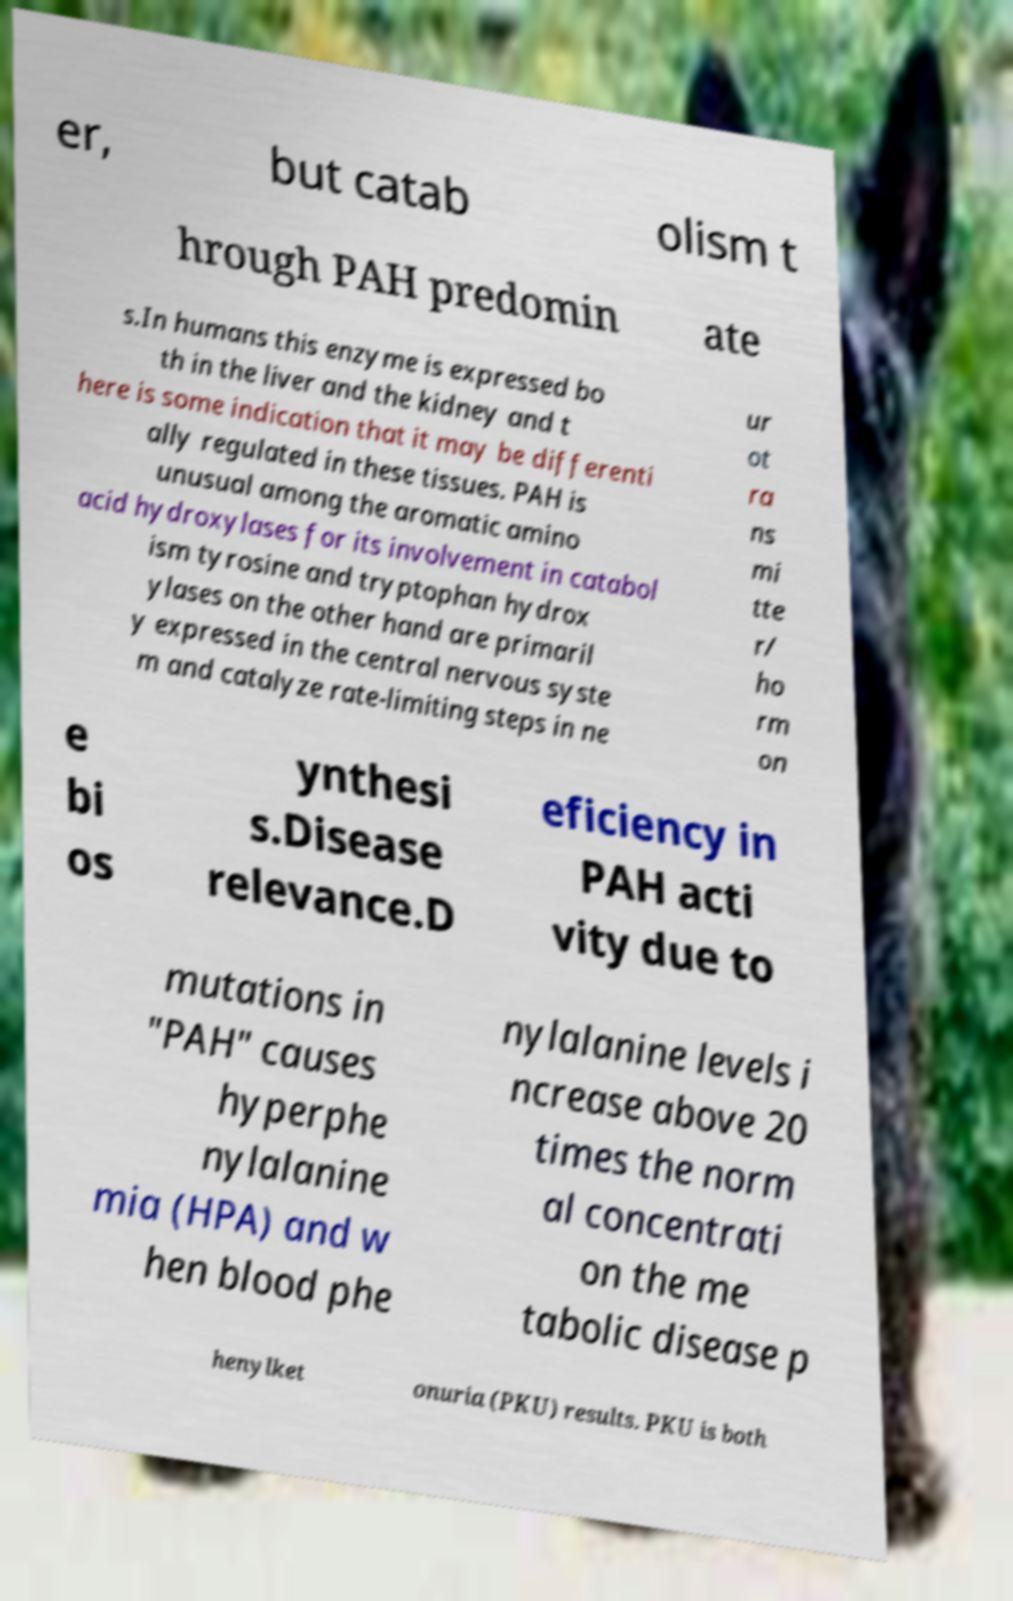Could you extract and type out the text from this image? er, but catab olism t hrough PAH predomin ate s.In humans this enzyme is expressed bo th in the liver and the kidney and t here is some indication that it may be differenti ally regulated in these tissues. PAH is unusual among the aromatic amino acid hydroxylases for its involvement in catabol ism tyrosine and tryptophan hydrox ylases on the other hand are primaril y expressed in the central nervous syste m and catalyze rate-limiting steps in ne ur ot ra ns mi tte r/ ho rm on e bi os ynthesi s.Disease relevance.D eficiency in PAH acti vity due to mutations in "PAH" causes hyperphe nylalanine mia (HPA) and w hen blood phe nylalanine levels i ncrease above 20 times the norm al concentrati on the me tabolic disease p henylket onuria (PKU) results. PKU is both 